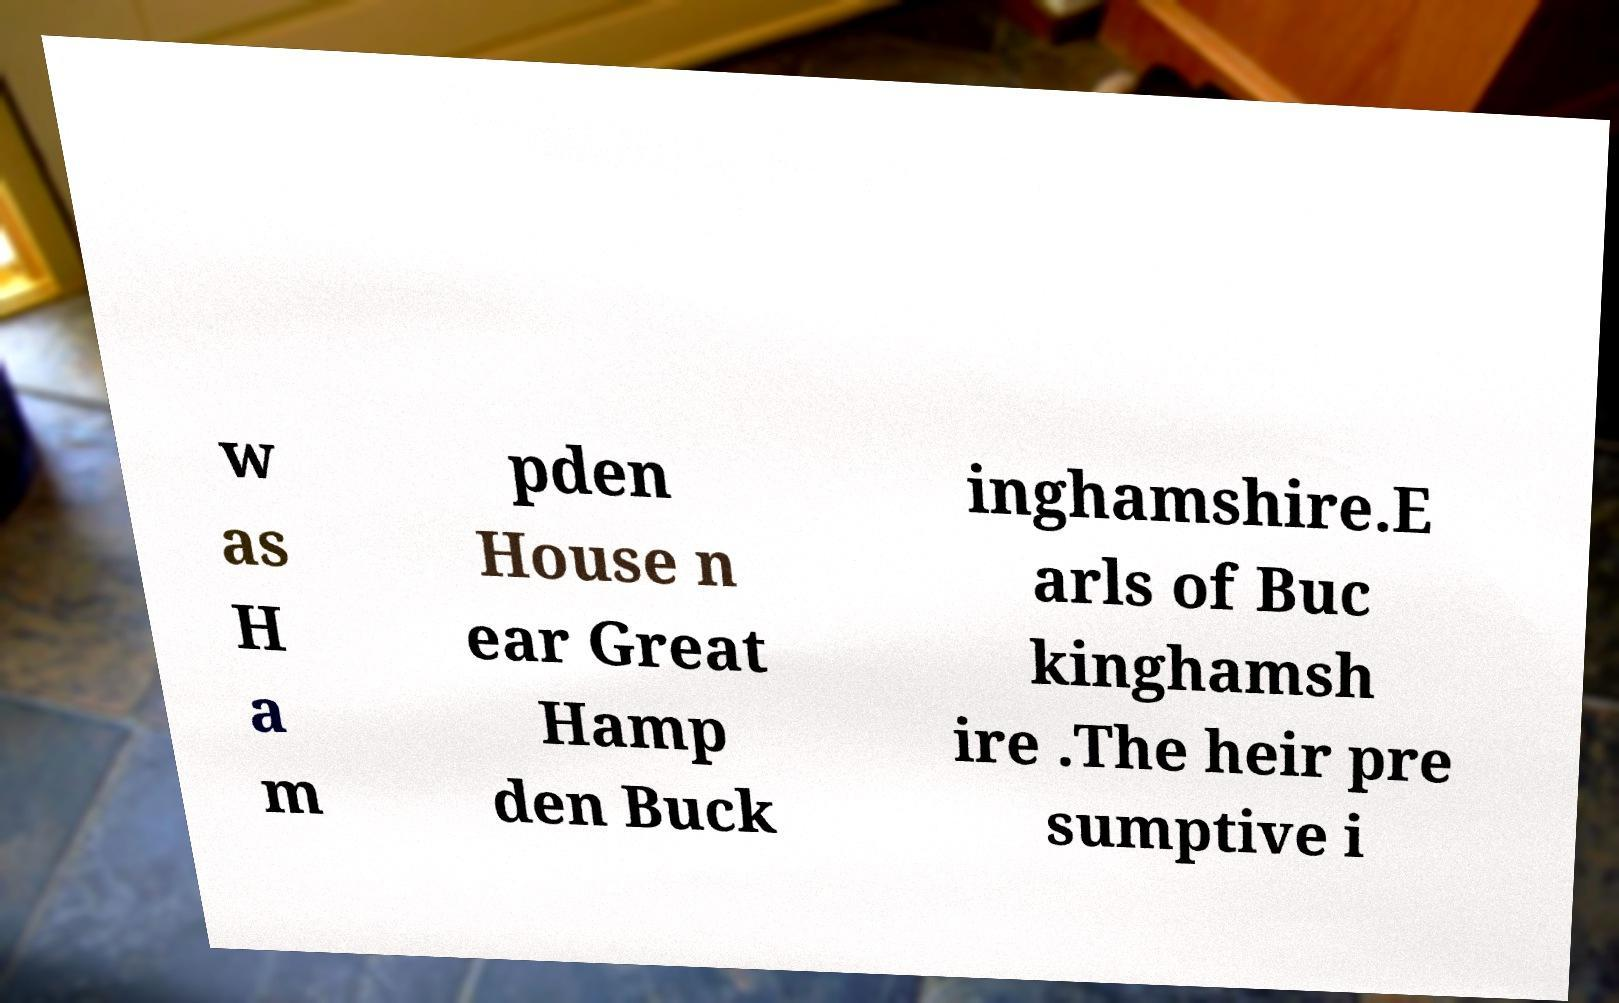Please identify and transcribe the text found in this image. w as H a m pden House n ear Great Hamp den Buck inghamshire.E arls of Buc kinghamsh ire .The heir pre sumptive i 